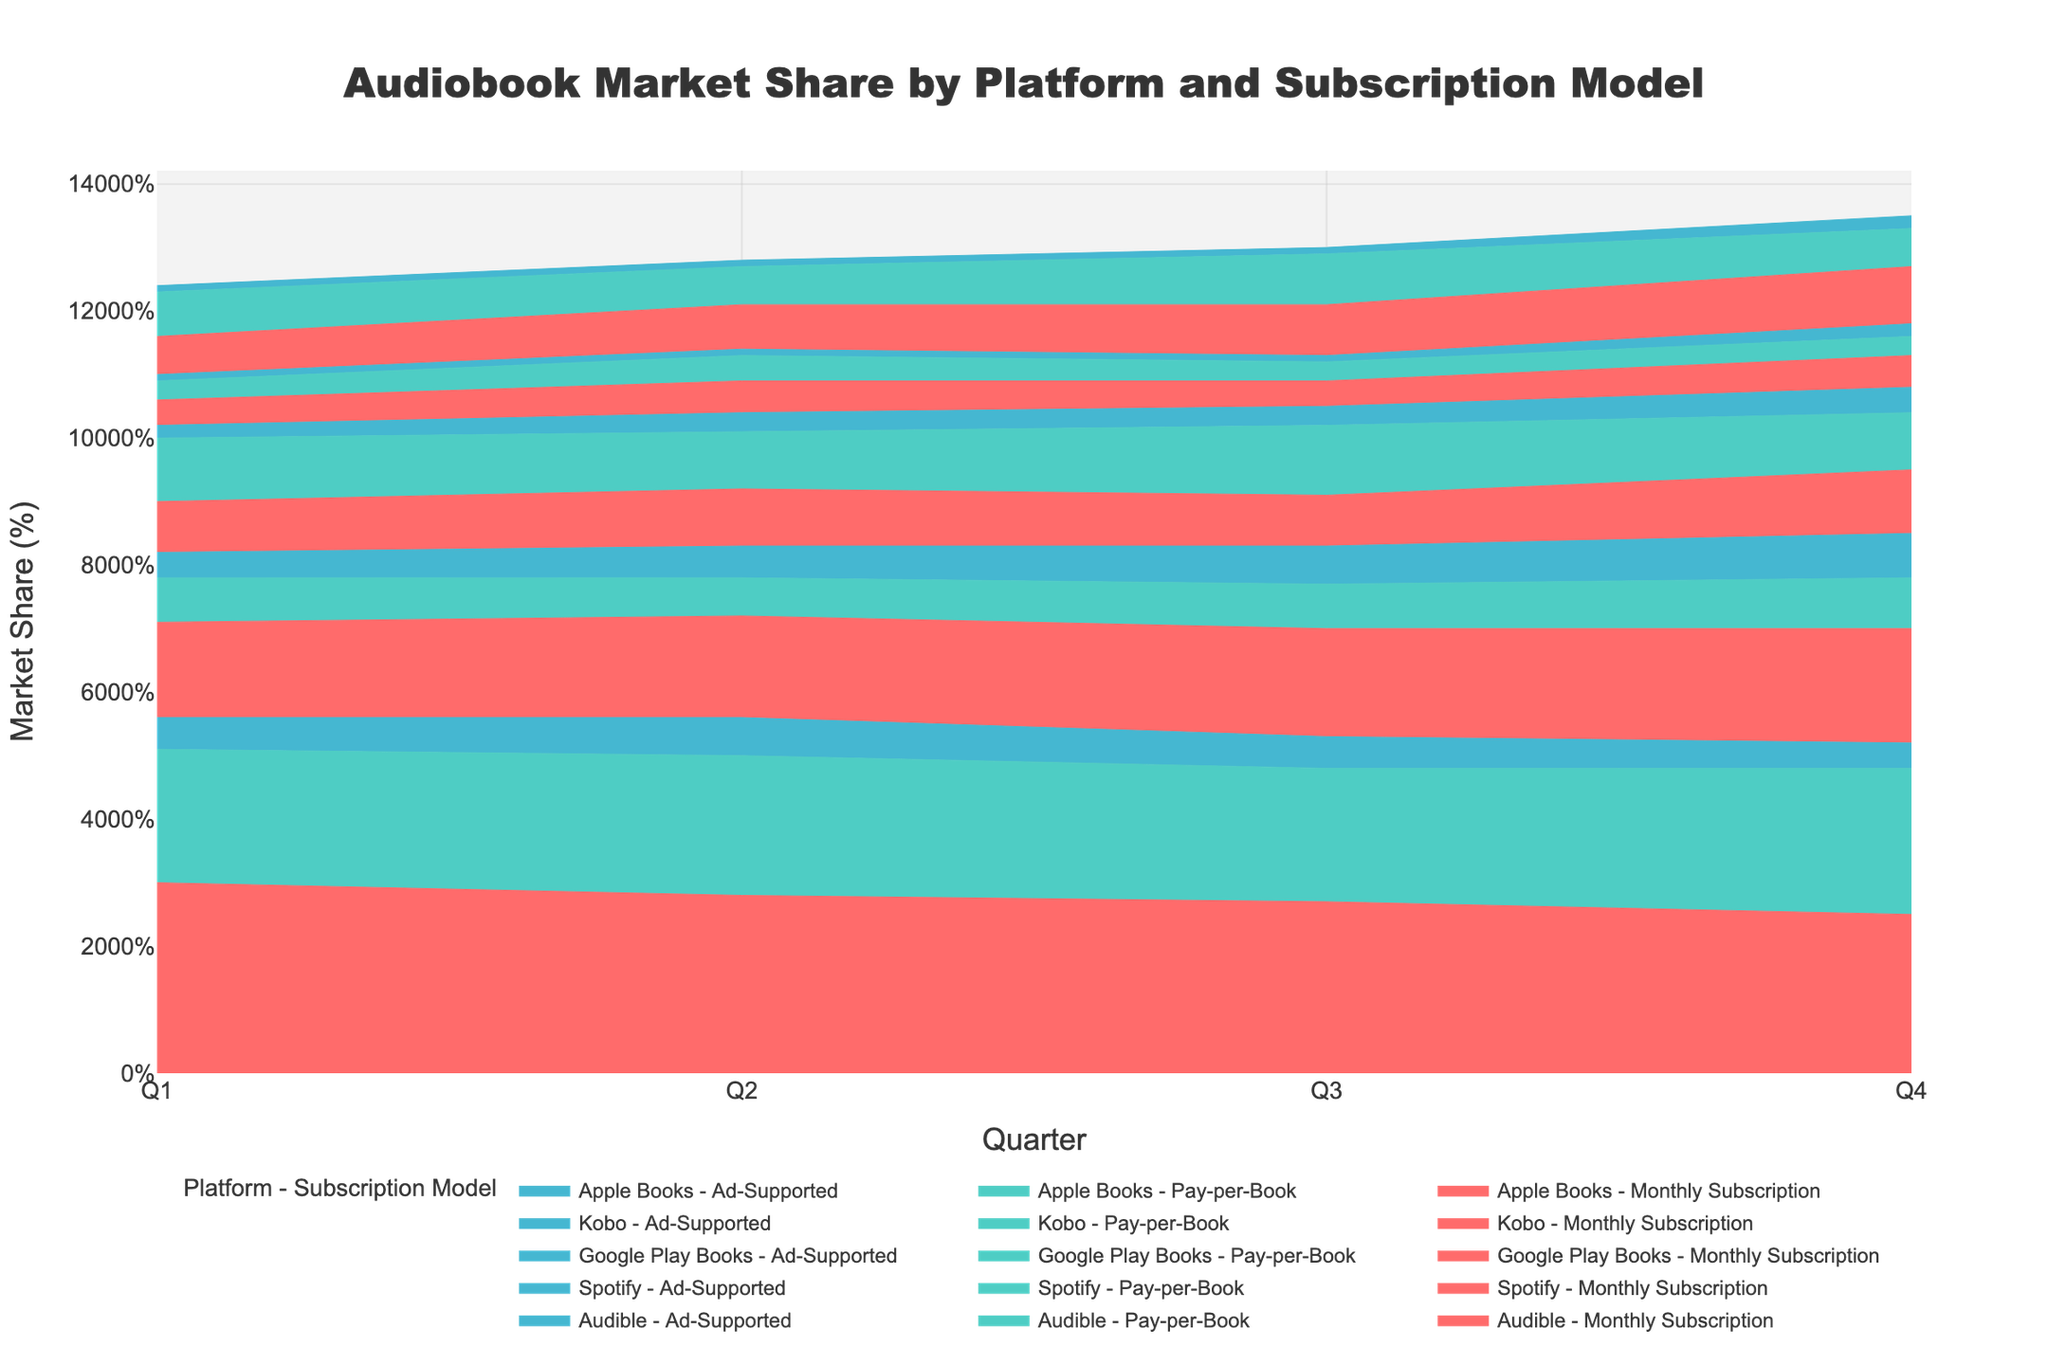What platforms have a monthly subscription model? The title and legend indicate platforms and subscription models. Check the legend for 'Monthly Subscription' entries.
Answer: Audible, Spotify, Google Play Books, Kobo, Apple Books How did Audible’s pay-per-book market share change from Q1 to Q4? Identify the line for “Audible - Pay-per-Book” in the legend and track its progression across Q1 to Q4 on the y-axis.
Answer: Increased from 21% to 23% What quarter shows the highest market share for Spotify's ad-supported model? Find the line for "Spotify - Ad-Supported" and compare the values across all quarters, noting the peak.
Answer: Q4 Which platform and subscription model had a market share of 10% or higher in Q4? Examine all lines at Q4 and identify those that reach or exceed 10%.
Answer: Google Play Books - Monthly Subscription, Audible - Pay-per-Book What are the combined market shares of all ad-supported models in Q3? Locate all ad-supported models in Q3, sum their market shares: Audible (5%), Spotify (6%), Google Play Books (3%), Kobo (1%), Apple Books (1%).
Answer: 16% Compare the market share growth of Spotify’s monthly subscription model to Apple Books’ monthly subscription model from Q1 to Q4. Find the lines for both models and compare the increase: Spotify (15% to 18%), Apple Books (6% to 9%).
Answer: Spotify: 3%, Apple Books: 3% How did Google Play Books' pay-per-book model's market share evolve across the four quarters? Track Google Play Books - Pay-per-Book line: Q1 (10%), Q2 (9%), Q3 (11%), Q4 (9%).
Answer: Varied with ups and downs What subscription model experienced the smallest market share in Q1? Check the y-axis values for all models in Q1 and find the minimum share.
Answer: Kobo - Ad-Supported (1%) Which platform saw a decrease in its monthly subscription market share from Q1 to Q4? Identify the platform lines for "Monthly Subscription" that decline from Q1 to Q4.
Answer: Audible (30% to 25%) How much did the market share of Spotify's ad-supported model increase from Q1 to Q4? Track the change in Spotify - Ad-Supported line from Q1 (4%) to Q4 (7%).
Answer: 3% 